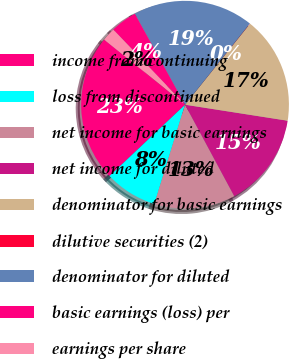Convert chart. <chart><loc_0><loc_0><loc_500><loc_500><pie_chart><fcel>income from continuing<fcel>loss from discontinued<fcel>net income for basic earnings<fcel>net income for diluted<fcel>denominator for basic earnings<fcel>dilutive securities (2)<fcel>denominator for diluted<fcel>basic earnings (loss) per<fcel>earnings per share<nl><fcel>22.84%<fcel>8.19%<fcel>12.63%<fcel>14.68%<fcel>16.72%<fcel>0.03%<fcel>18.76%<fcel>4.11%<fcel>2.07%<nl></chart> 